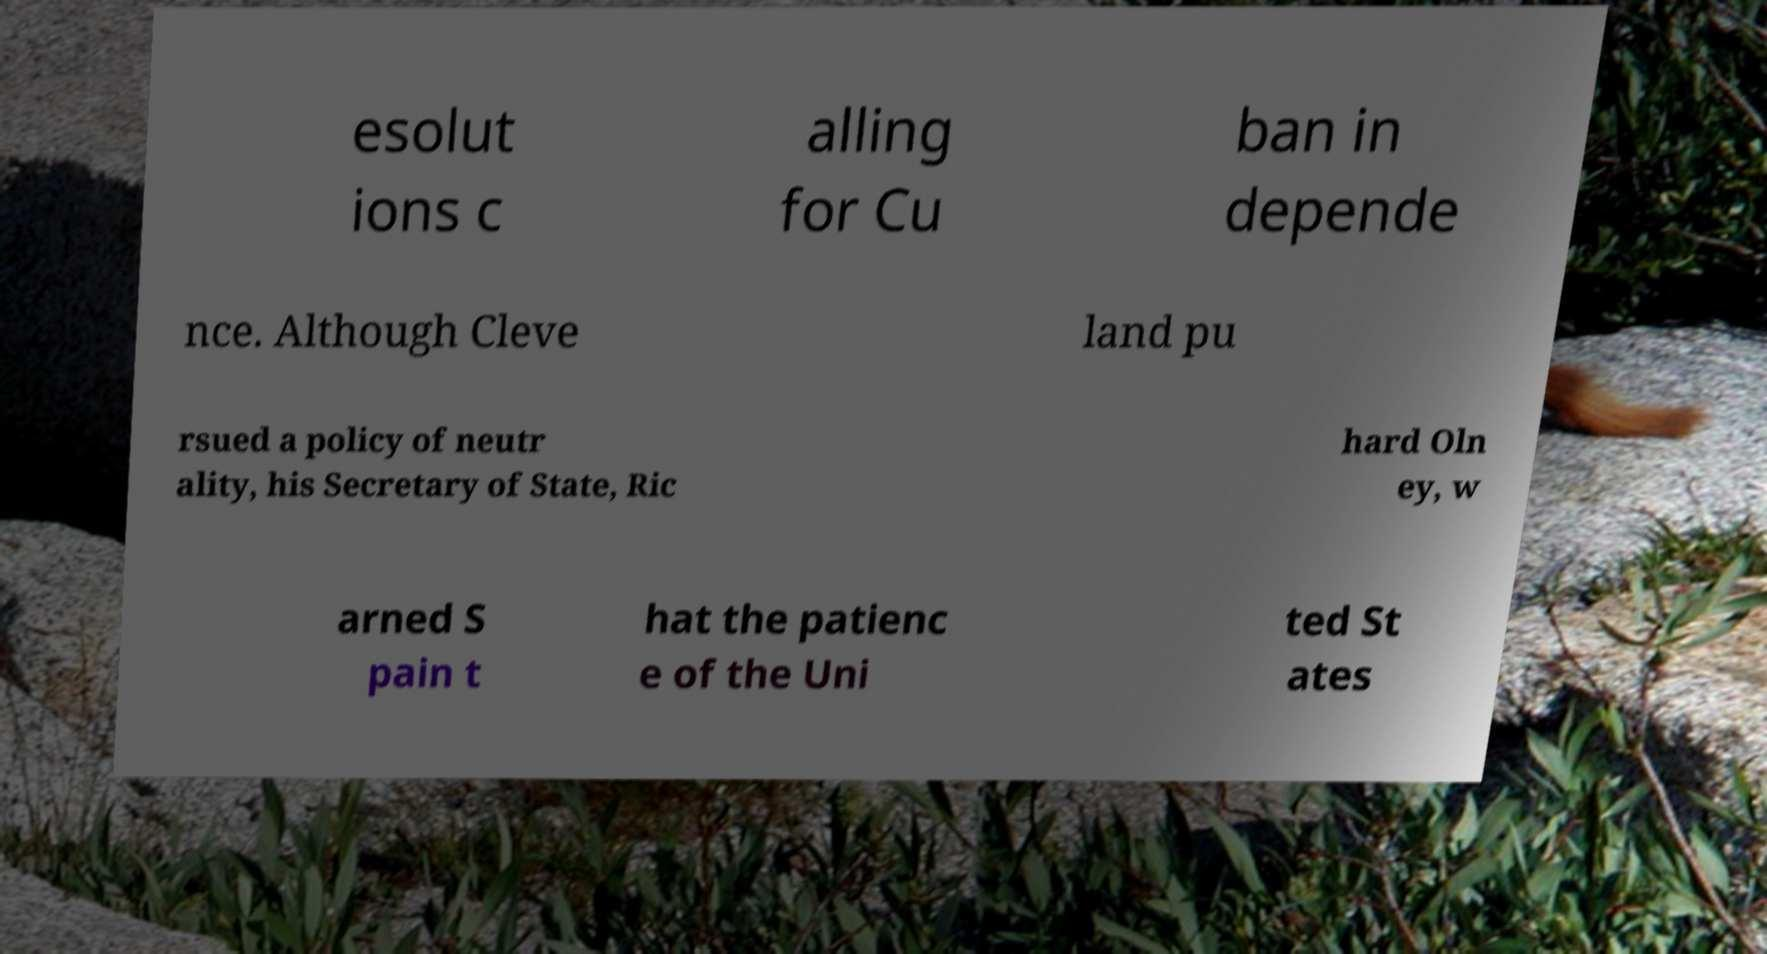Can you read and provide the text displayed in the image?This photo seems to have some interesting text. Can you extract and type it out for me? esolut ions c alling for Cu ban in depende nce. Although Cleve land pu rsued a policy of neutr ality, his Secretary of State, Ric hard Oln ey, w arned S pain t hat the patienc e of the Uni ted St ates 